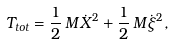Convert formula to latex. <formula><loc_0><loc_0><loc_500><loc_500>T _ { t o t } = \frac { 1 } { 2 } \, M \dot { X } ^ { 2 } + \frac { 1 } { 2 } \, M \dot { \xi } ^ { 2 } ,</formula> 